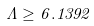Convert formula to latex. <formula><loc_0><loc_0><loc_500><loc_500>\Lambda \geq 6 . 1 3 9 2</formula> 